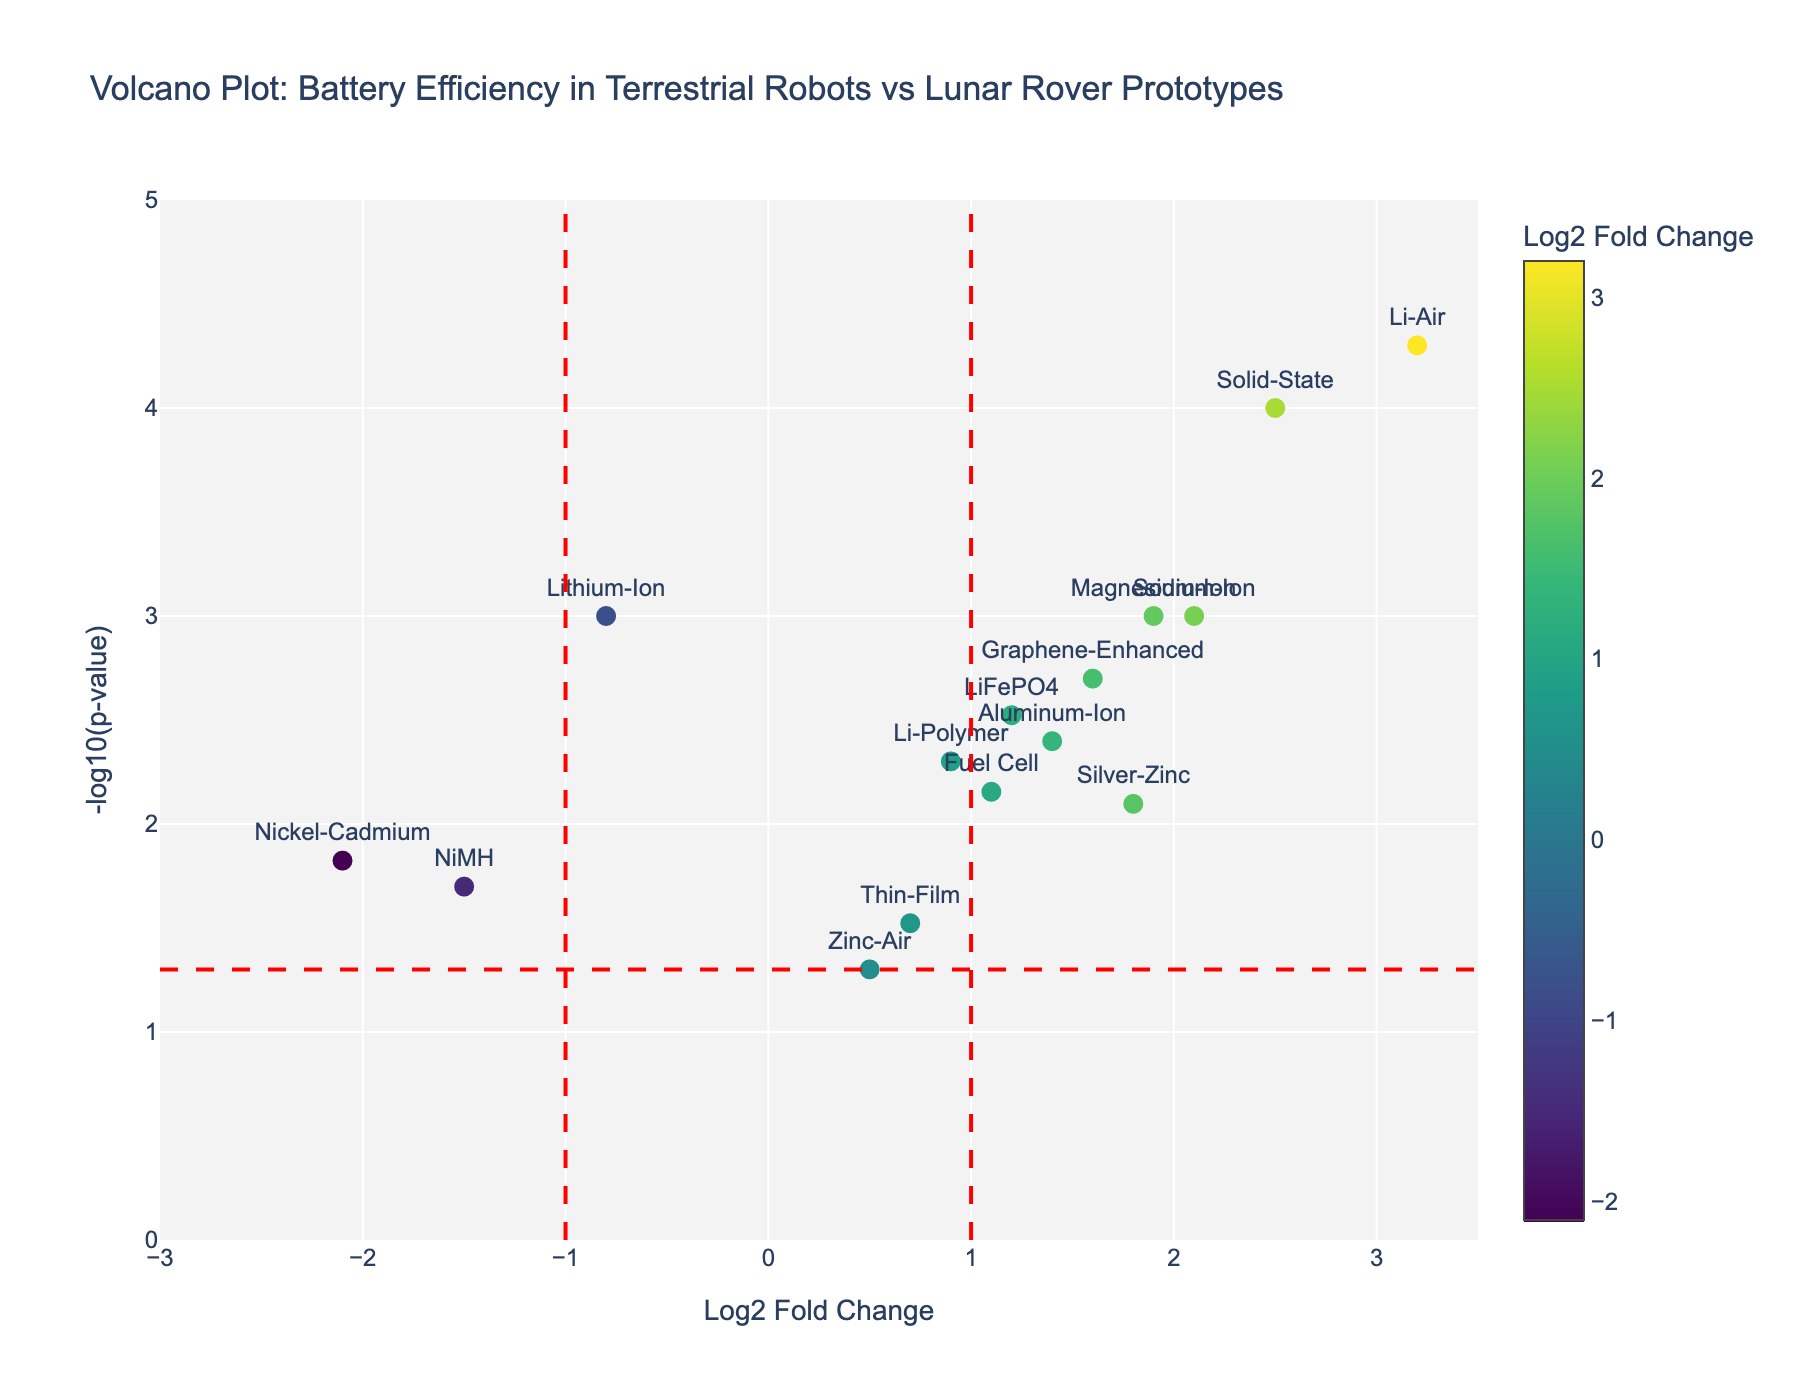How many battery types are represented in this Volcano Plot? Count the number of unique data points (batteries) in the figure, which are labeled with their names.
Answer: 15 What is the Log2 Fold Change value for the battery type with the highest efficiency? Look for the battery type that has the highest y-value (indicating the lowest p-value) and the most positive x-value (highest Log2 Fold Change). This is the "Li-Air" battery with a Log2 Fold Change of 3.2.
Answer: 3.2 How many battery types have a p-value less than 0.01? Identify points above the horizontal red dashed line, as this line represents a p-value threshold of 0.05. Count the data points above this line.
Answer: 10 Which battery type shows the least efficiency in lunar rover prototypes compared to terrestrial robots? Look for the battery type with the most negative Log2 Fold Change value. This is the "Nickel-Cadmium" battery with a Log2 Fold Change of -2.1.
Answer: Nickel-Cadmium What is the significance threshold for the p-value in this plot? Observe the position of the horizontal red dashed line, which corresponds to the p-value threshold. The y-axis value at this line is -log10(0.05).
Answer: 0.05 How does the efficiency of the Silver-Zinc battery compare to the Graphene-Enhanced battery? Compare the Log2 Fold Change values of both batteries: Silver-Zinc (1.8) and Graphene-Enhanced (1.6). Silver-Zinc has a higher Log2 Fold Change value.
Answer: Silver-Zinc is more efficient What are the Log2 Fold Change and p-value for the battery type with the highest significance? "Li-Air" has the highest significance with the highest y-value (-log10(p-value)). Its Log2 Fold Change is 3.2, and the p-value is 0.00005.
Answer: Log2 Fold Change: 3.2, p-value: 0.00005 If a battery type has a Log2 Fold Change greater than 1 and an efficiency p-value less than 0.01, how many battery types qualify? Observe battery types with Log2 Fold Change values greater than 1 and p-values less than 0.01. These are LiFePO4, Li-Polymer, Silver-Zinc, Aluminum-Ion, Graphene-Enhanced, Sodium-Ion, Solid-State, Magnesium-Ion, Li-Air, and Fuel Cell, totaling 10.
Answer: 10 